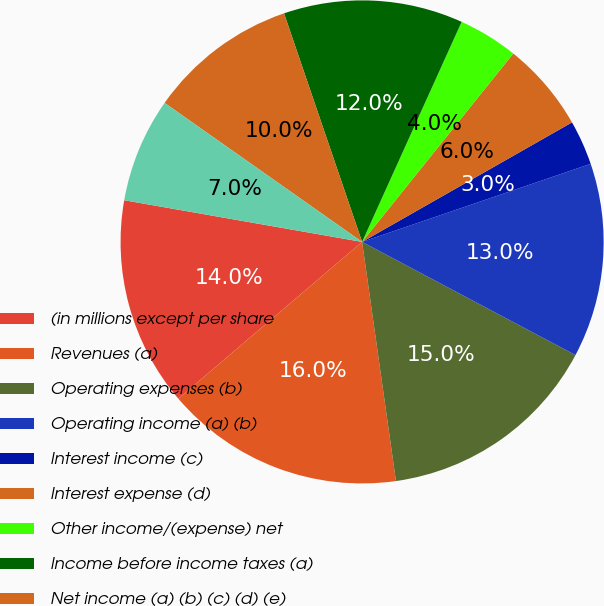<chart> <loc_0><loc_0><loc_500><loc_500><pie_chart><fcel>(in millions except per share<fcel>Revenues (a)<fcel>Operating expenses (b)<fcel>Operating income (a) (b)<fcel>Interest income (c)<fcel>Interest expense (d)<fcel>Other income/(expense) net<fcel>Income before income taxes (a)<fcel>Net income (a) (b) (c) (d) (e)<fcel>Depreciation and amortization<nl><fcel>14.0%<fcel>16.0%<fcel>15.0%<fcel>13.0%<fcel>3.0%<fcel>6.0%<fcel>4.0%<fcel>12.0%<fcel>10.0%<fcel>7.0%<nl></chart> 